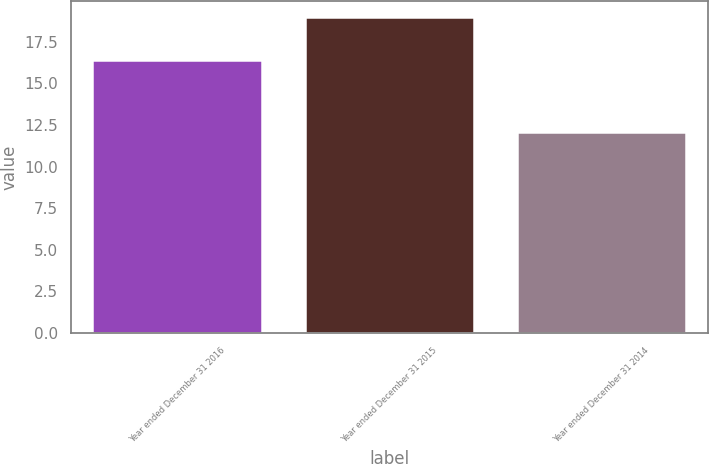Convert chart. <chart><loc_0><loc_0><loc_500><loc_500><bar_chart><fcel>Year ended December 31 2016<fcel>Year ended December 31 2015<fcel>Year ended December 31 2014<nl><fcel>16.4<fcel>19<fcel>12.1<nl></chart> 